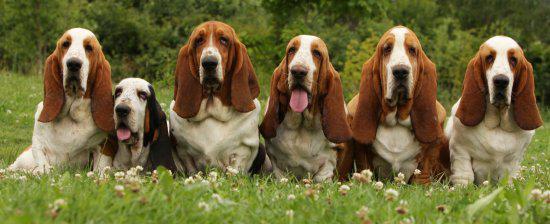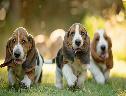The first image is the image on the left, the second image is the image on the right. Considering the images on both sides, is "There are three dogs" valid? Answer yes or no. No. The first image is the image on the left, the second image is the image on the right. For the images displayed, is the sentence "Exactly three bassett hounds are pictured, two of them side by side." factually correct? Answer yes or no. No. 